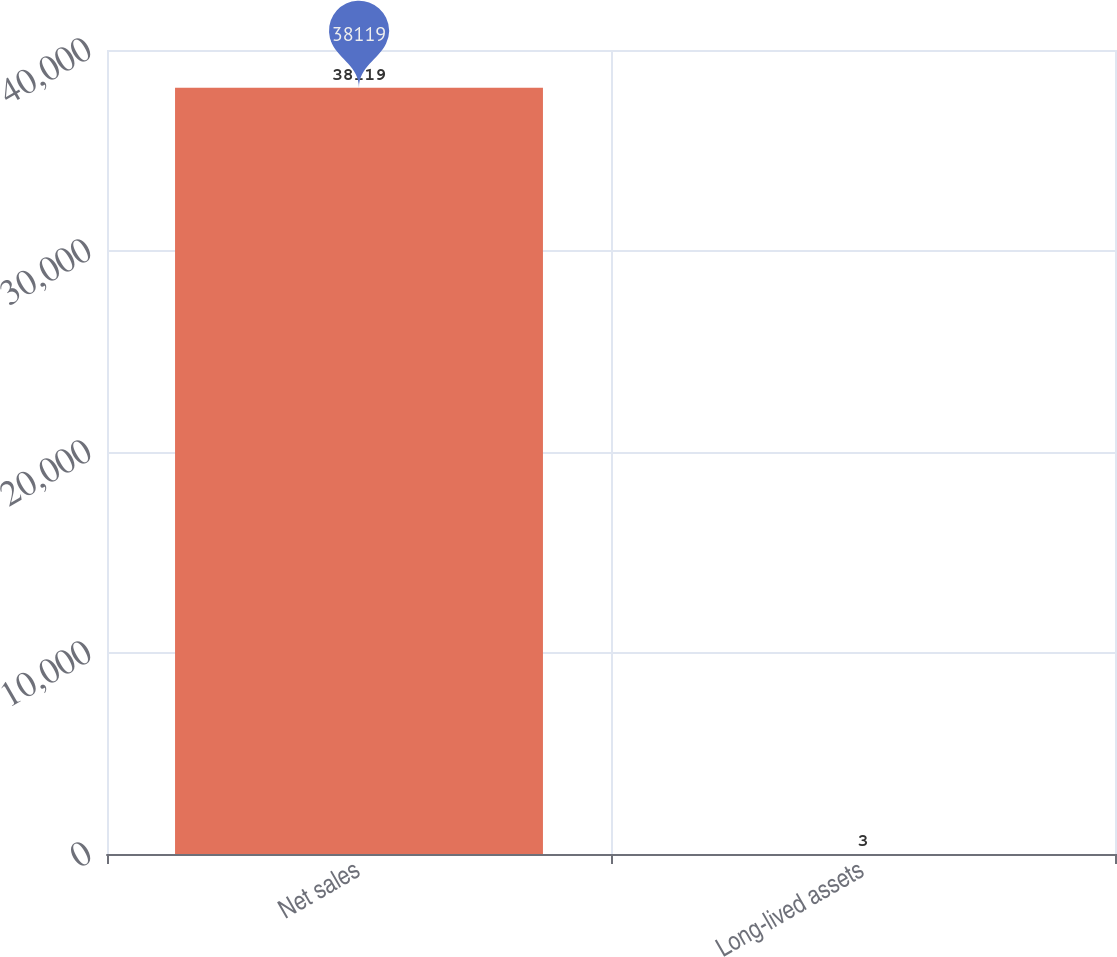<chart> <loc_0><loc_0><loc_500><loc_500><bar_chart><fcel>Net sales<fcel>Long-lived assets<nl><fcel>38119<fcel>3<nl></chart> 